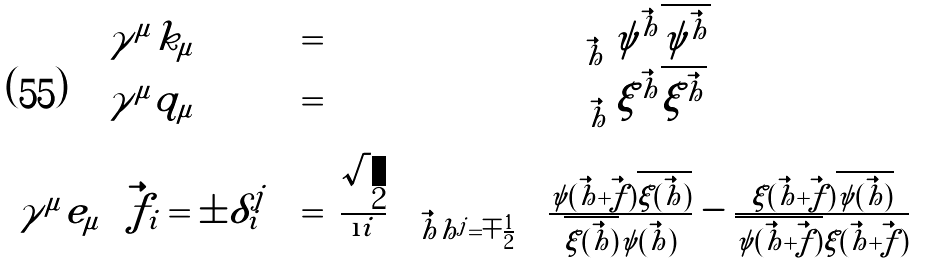Convert formula to latex. <formula><loc_0><loc_0><loc_500><loc_500>\begin{array} { c c c } \gamma ^ { \mu } k _ { \mu } & = & \sum _ { \vec { h } } \psi ^ { \vec { h } } \overline { \psi ^ { \vec { h } } } \\ \gamma ^ { \mu } q _ { \mu } & = & \sum _ { \vec { h } } \xi ^ { \vec { h } } \overline { \xi ^ { \vec { h } } } \\ \gamma ^ { \mu } e _ { \mu } \left ( \vec { f } _ { i } = \pm \delta _ { i } ^ { j } \right ) & = & \frac { \sqrt { 2 } } { \i i } \sum _ { \vec { h } | h ^ { j } = \mp \frac { 1 } { 2 } } \left ( \frac { \psi ( \vec { h } + \vec { f } ) \overline { \xi ( \vec { h } ) } } { \overline { \xi ( \vec { h } ) } \psi ( \vec { h } ) } - \frac { \xi ( \vec { h } + \vec { f } ) \overline { \psi ( \vec { h } ) } } { \overline { \psi ( \vec { h } + \vec { f } ) } \xi ( \vec { h } + \vec { f } ) } \right ) \end{array}</formula> 